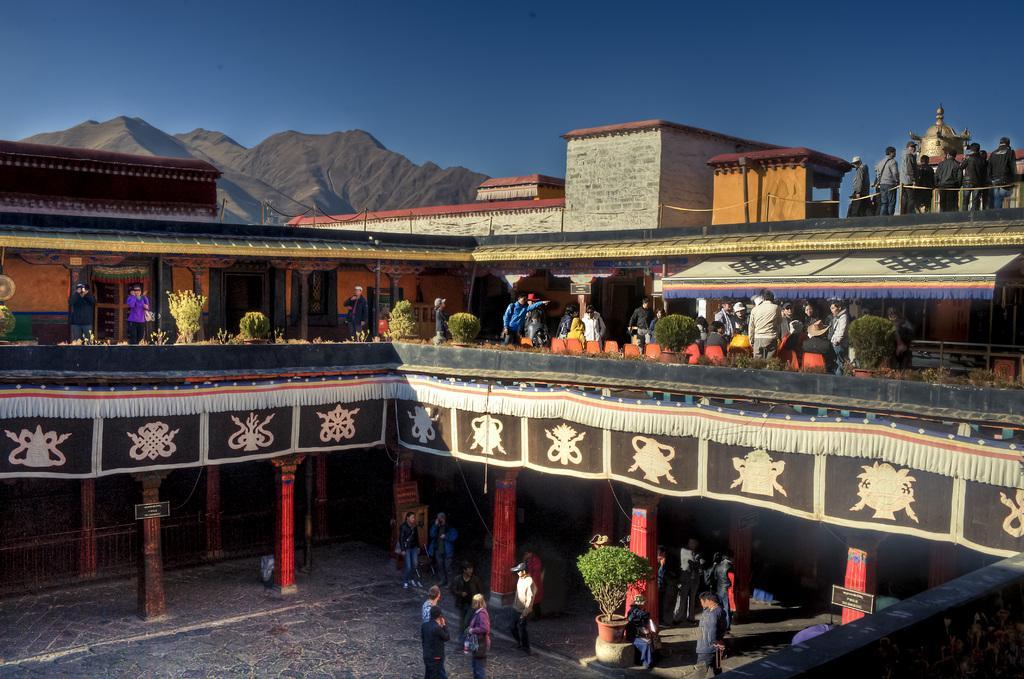How would you summarize this image in a sentence or two? In this picture we can see a building here, there are some people standing here, we can see some plants and a cloth here, in the background there is a hill, we can see pillars here, there is a board here, we can see sky at the top of the picture. 